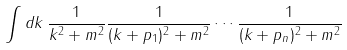<formula> <loc_0><loc_0><loc_500><loc_500>\int d k \, { \frac { 1 } { k ^ { 2 } + m ^ { 2 } } } { \frac { 1 } { ( k + p _ { 1 } ) ^ { 2 } + m ^ { 2 } } } \cdots { \frac { 1 } { ( k + p _ { n } ) ^ { 2 } + m ^ { 2 } } }</formula> 